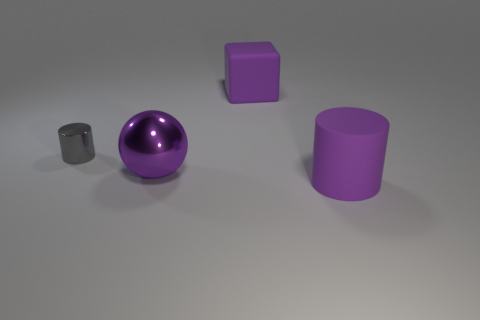Are there any cyan shiny blocks that have the same size as the matte cylinder?
Ensure brevity in your answer.  No. What number of objects are purple objects to the left of the large cylinder or metallic objects?
Ensure brevity in your answer.  3. Are the sphere and the purple thing to the right of the big purple cube made of the same material?
Your answer should be very brief. No. What number of other things are the same shape as the gray shiny object?
Ensure brevity in your answer.  1. What number of objects are either large purple matte things behind the gray shiny cylinder or large rubber objects behind the gray thing?
Your answer should be very brief. 1. What number of other objects are the same color as the small metal thing?
Your answer should be compact. 0. Is the number of purple metal spheres right of the big metallic ball less than the number of large purple matte cubes left of the tiny shiny cylinder?
Ensure brevity in your answer.  No. How many large spheres are there?
Keep it short and to the point. 1. Are there fewer big metallic things that are left of the small gray shiny cylinder than small yellow metallic objects?
Make the answer very short. No. Does the object that is in front of the purple sphere have the same shape as the tiny thing?
Make the answer very short. Yes. 